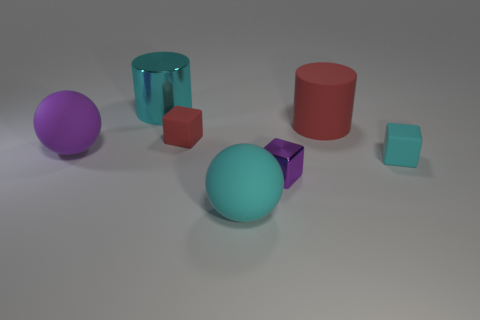Subtract 1 balls. How many balls are left? 1 Subtract all small rubber cubes. How many cubes are left? 1 Add 3 big metallic blocks. How many objects exist? 10 Subtract all spheres. How many objects are left? 5 Subtract all blue balls. Subtract all blue cylinders. How many balls are left? 2 Subtract all gray cubes. How many cyan balls are left? 1 Subtract all big cylinders. Subtract all small red objects. How many objects are left? 4 Add 7 big spheres. How many big spheres are left? 9 Add 6 green cubes. How many green cubes exist? 6 Subtract all cyan blocks. How many blocks are left? 2 